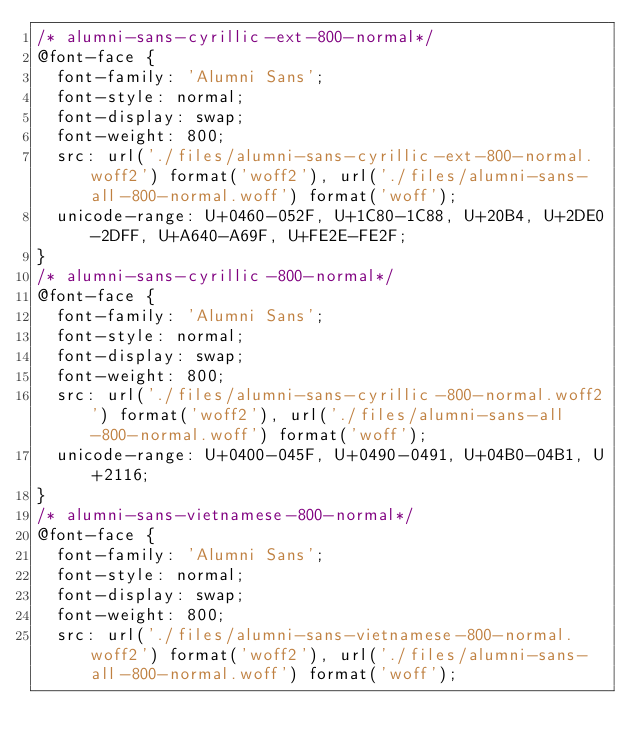Convert code to text. <code><loc_0><loc_0><loc_500><loc_500><_CSS_>/* alumni-sans-cyrillic-ext-800-normal*/
@font-face {
  font-family: 'Alumni Sans';
  font-style: normal;
  font-display: swap;
  font-weight: 800;
  src: url('./files/alumni-sans-cyrillic-ext-800-normal.woff2') format('woff2'), url('./files/alumni-sans-all-800-normal.woff') format('woff');
  unicode-range: U+0460-052F, U+1C80-1C88, U+20B4, U+2DE0-2DFF, U+A640-A69F, U+FE2E-FE2F;
}
/* alumni-sans-cyrillic-800-normal*/
@font-face {
  font-family: 'Alumni Sans';
  font-style: normal;
  font-display: swap;
  font-weight: 800;
  src: url('./files/alumni-sans-cyrillic-800-normal.woff2') format('woff2'), url('./files/alumni-sans-all-800-normal.woff') format('woff');
  unicode-range: U+0400-045F, U+0490-0491, U+04B0-04B1, U+2116;
}
/* alumni-sans-vietnamese-800-normal*/
@font-face {
  font-family: 'Alumni Sans';
  font-style: normal;
  font-display: swap;
  font-weight: 800;
  src: url('./files/alumni-sans-vietnamese-800-normal.woff2') format('woff2'), url('./files/alumni-sans-all-800-normal.woff') format('woff');</code> 